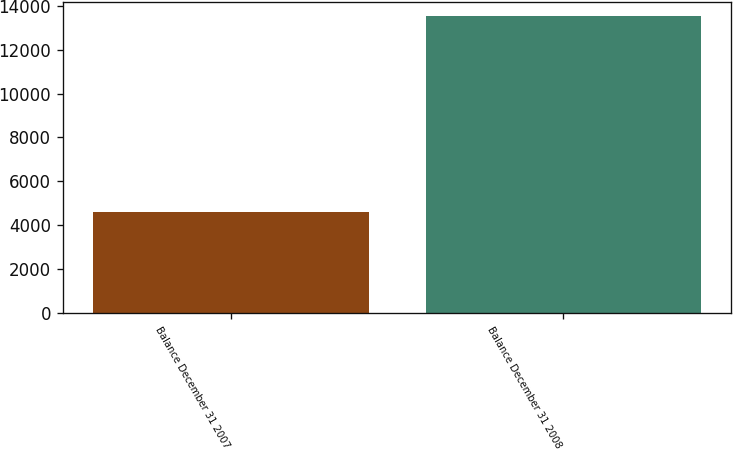Convert chart to OTSL. <chart><loc_0><loc_0><loc_500><loc_500><bar_chart><fcel>Balance December 31 2007<fcel>Balance December 31 2008<nl><fcel>4596<fcel>13525<nl></chart> 